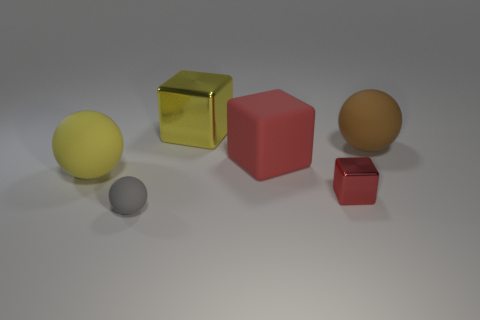How many big things are the same color as the tiny metallic thing?
Your response must be concise. 1. How many large things are either brown rubber spheres or yellow objects?
Your answer should be very brief. 3. The metallic cube that is the same color as the matte block is what size?
Your answer should be very brief. Small. Are there any big yellow spheres that have the same material as the tiny gray thing?
Provide a succinct answer. Yes. There is a big yellow thing that is left of the gray matte object; what is it made of?
Offer a terse response. Rubber. Does the thing behind the big brown matte ball have the same color as the big object in front of the big red matte thing?
Make the answer very short. Yes. The matte block that is the same size as the brown matte ball is what color?
Your answer should be compact. Red. What number of other things are there of the same shape as the large red matte thing?
Your answer should be compact. 2. What size is the yellow thing behind the rubber block?
Offer a very short reply. Large. There is a large rubber sphere on the left side of the tiny red metal cube; what number of big yellow metal things are in front of it?
Keep it short and to the point. 0. 